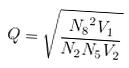<formula> <loc_0><loc_0><loc_500><loc_500>Q = \sqrt { \frac { { N _ { 8 } } ^ { 2 } V _ { 1 } } { N _ { 2 } N _ { 5 } V _ { 2 } } }</formula> 